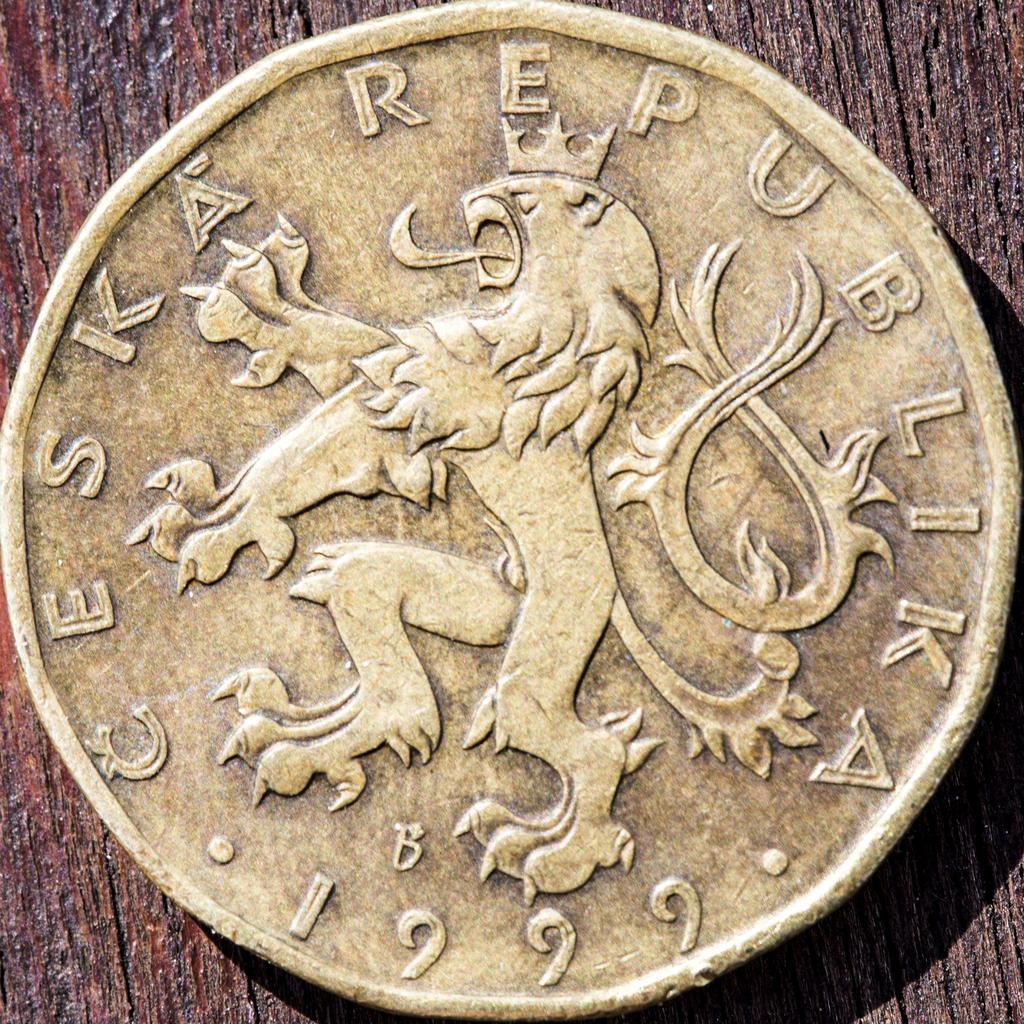What object can be seen in the image? There is a coin in the image. What type of bells can be heard ringing in the image? There are no bells present in the image, and therefore no sounds can be heard. 